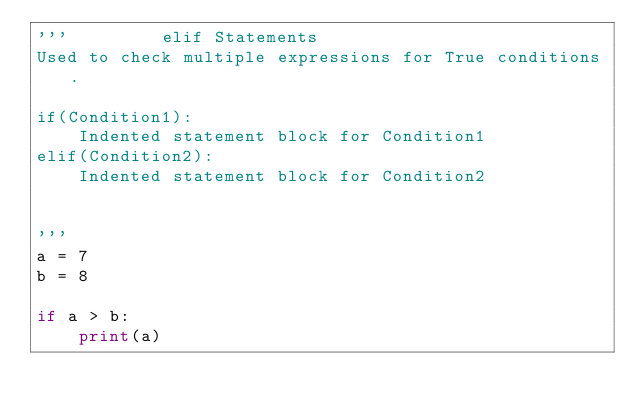Convert code to text. <code><loc_0><loc_0><loc_500><loc_500><_Python_>'''         elif Statements
Used to check multiple expressions for True conditions.

if(Condition1):
    Indented statement block for Condition1
elif(Condition2):
    Indented statement block for Condition2


'''
a = 7
b = 8

if a > b:
    print(a)

</code> 